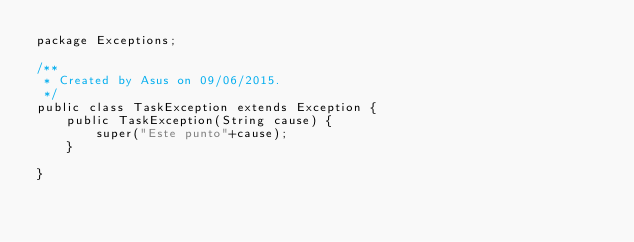Convert code to text. <code><loc_0><loc_0><loc_500><loc_500><_Java_>package Exceptions;

/**
 * Created by Asus on 09/06/2015.
 */
public class TaskException extends Exception {
    public TaskException(String cause) {
        super("Este punto"+cause);
    }

}
</code> 